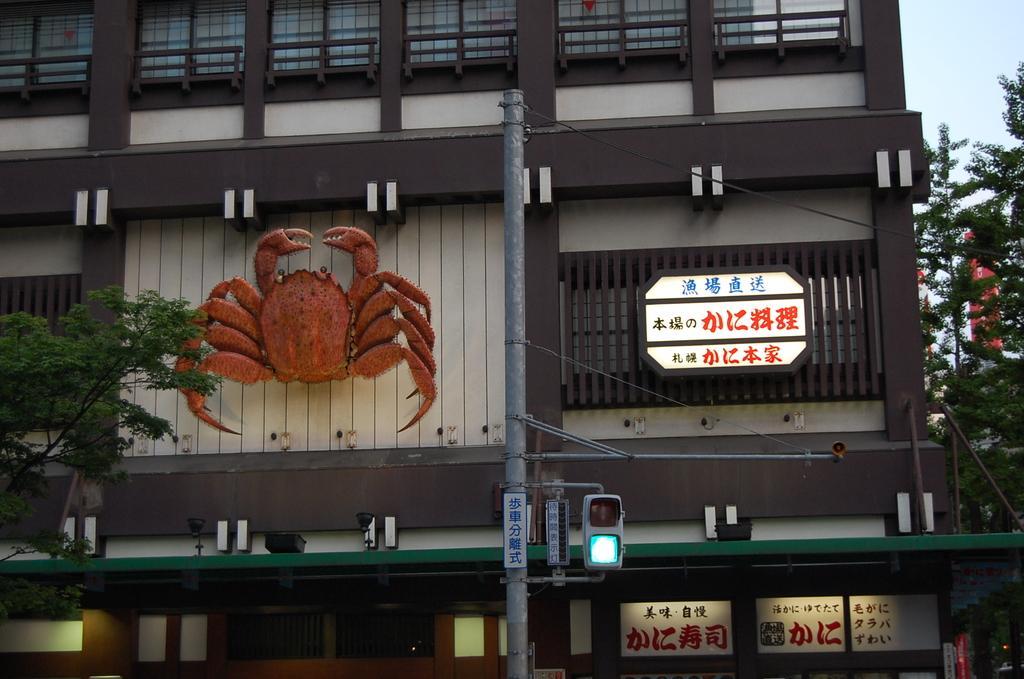How would you summarize this image in a sentence or two? In this picture we can see trees, boards, traffic signal, pole, statue on the wall and building. In the background of the image we can see a banner and sky. 